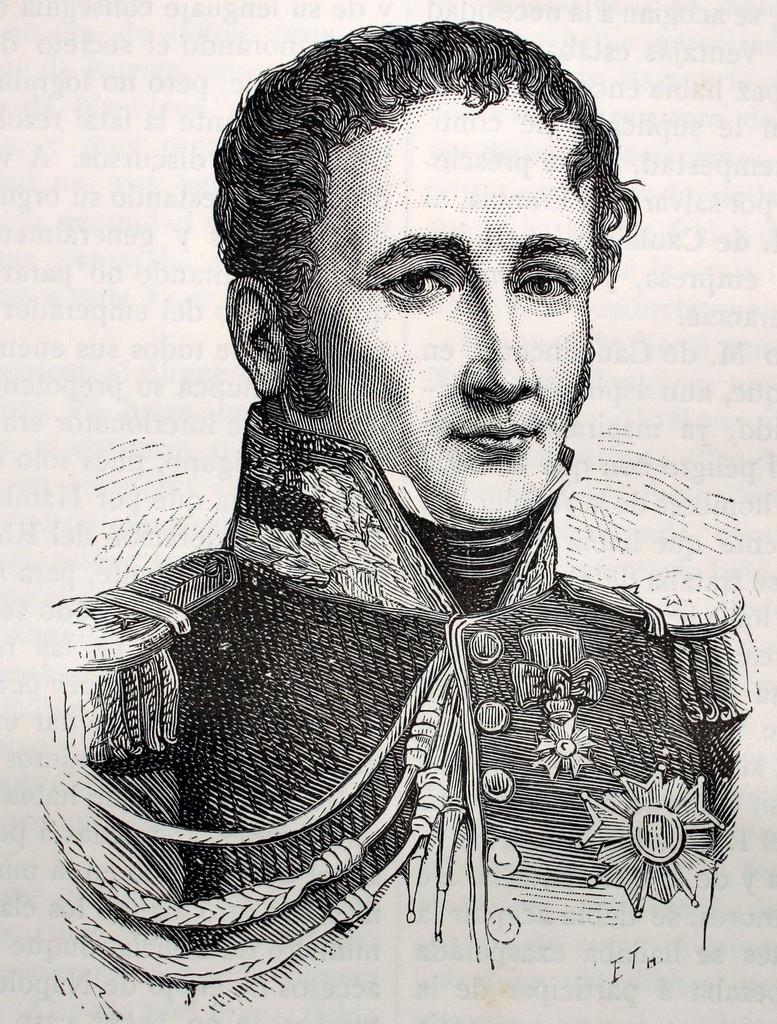What is the main subject of the image? There is a painting in the image. What does the painting depict? The painting depicts a person. How many chairs are present in the painting? There is no chair present in the painting; it only depicts a person. What type of company is featured in the painting? There is no company featured in the painting; it only depicts a person. 